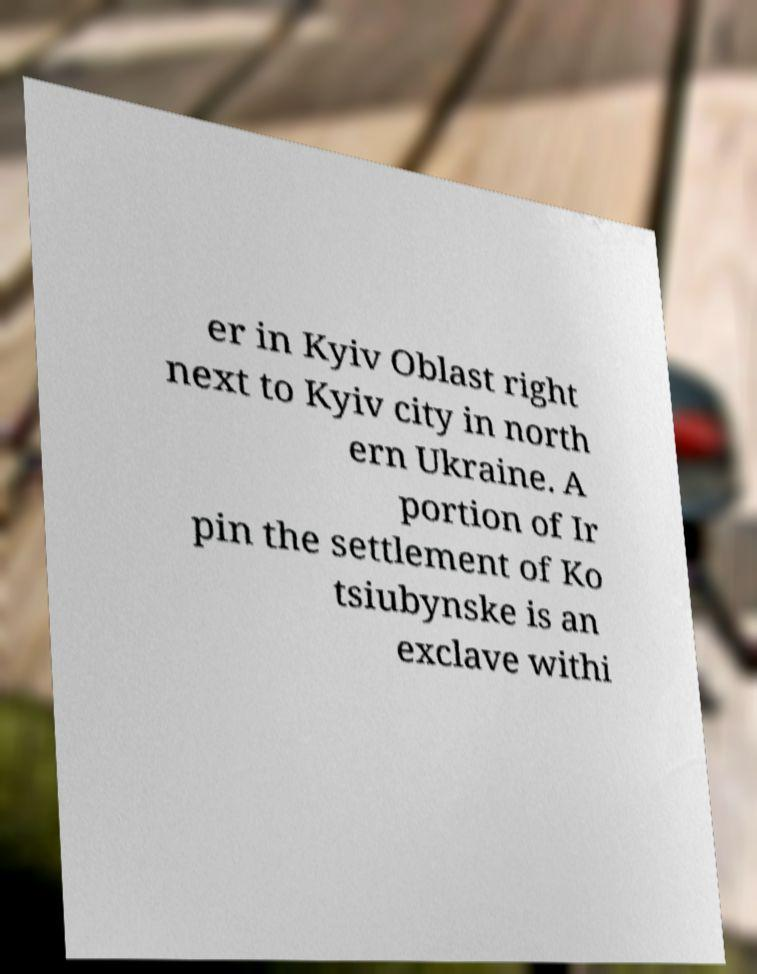Can you read and provide the text displayed in the image?This photo seems to have some interesting text. Can you extract and type it out for me? er in Kyiv Oblast right next to Kyiv city in north ern Ukraine. A portion of Ir pin the settlement of Ko tsiubynske is an exclave withi 